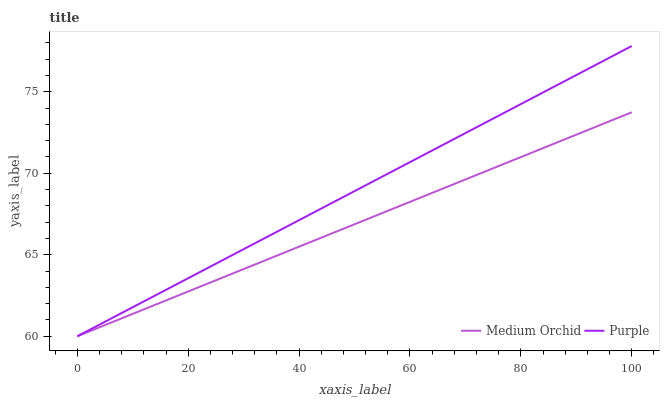Does Medium Orchid have the minimum area under the curve?
Answer yes or no. Yes. Does Purple have the maximum area under the curve?
Answer yes or no. Yes. Does Medium Orchid have the maximum area under the curve?
Answer yes or no. No. Is Medium Orchid the smoothest?
Answer yes or no. Yes. Is Purple the roughest?
Answer yes or no. Yes. Is Medium Orchid the roughest?
Answer yes or no. No. Does Purple have the highest value?
Answer yes or no. Yes. Does Medium Orchid have the highest value?
Answer yes or no. No. Does Medium Orchid intersect Purple?
Answer yes or no. Yes. Is Medium Orchid less than Purple?
Answer yes or no. No. Is Medium Orchid greater than Purple?
Answer yes or no. No. 